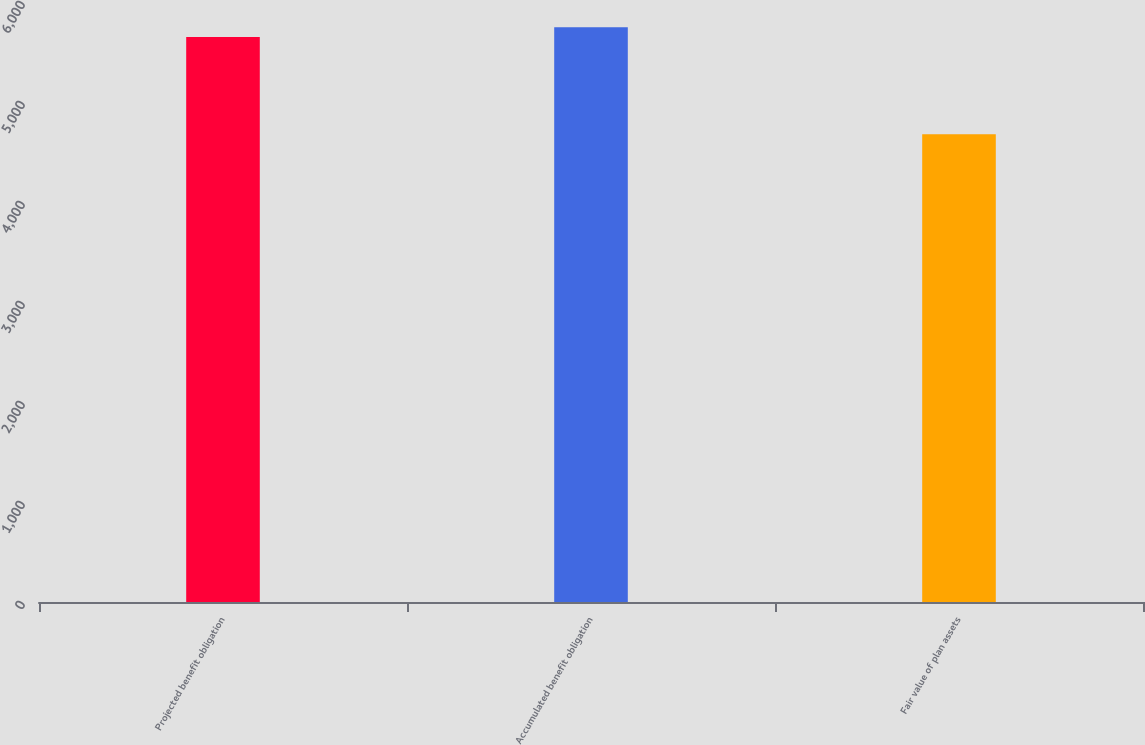Convert chart to OTSL. <chart><loc_0><loc_0><loc_500><loc_500><bar_chart><fcel>Projected benefit obligation<fcel>Accumulated benefit obligation<fcel>Fair value of plan assets<nl><fcel>5650<fcel>5747.2<fcel>4678<nl></chart> 